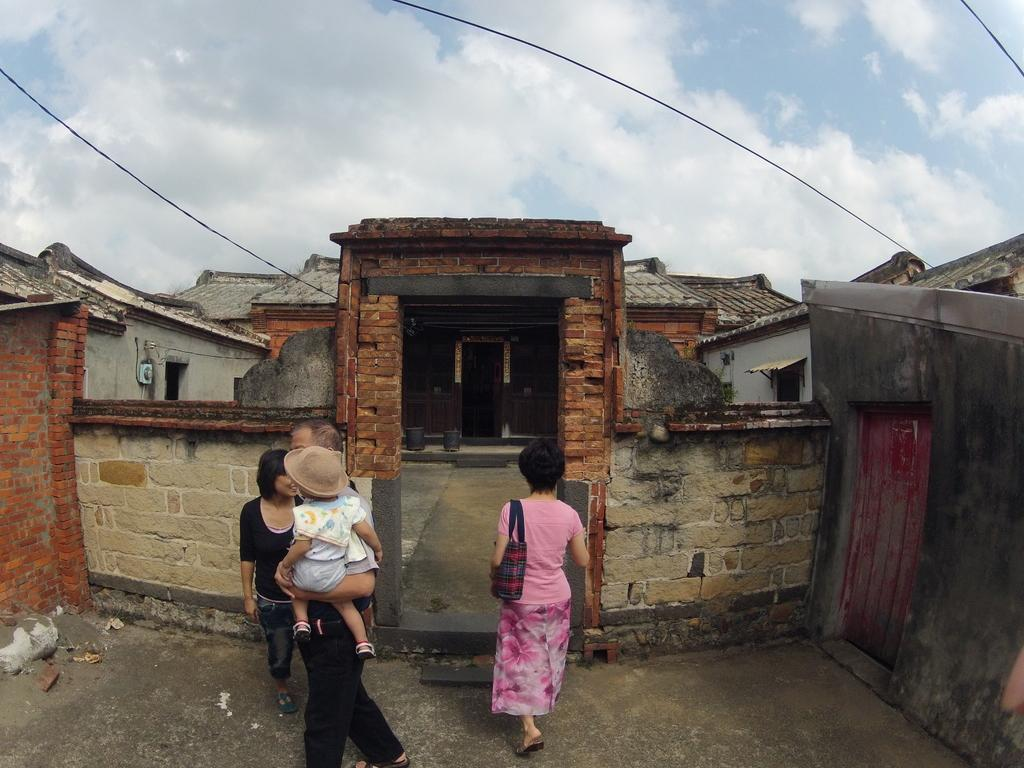What can be seen in the image involving people? There are people standing in the image. What type of structure is present in the image? There is a house in the image. What is visible in the background of the image? The sky is visible in the image. What else can be seen in the image besides people and the house? There are cables in the image. What type of horn can be seen on the plate in the image? There is no horn or plate present in the image. Can you describe the land in the image? The image does not show any specific land features; it only includes people, a house, the sky, and cables. 